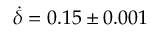<formula> <loc_0><loc_0><loc_500><loc_500>\dot { \delta } = 0 . 1 5 \pm 0 . 0 0 1</formula> 